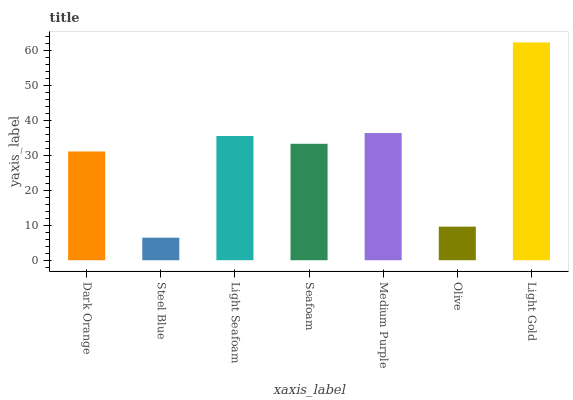Is Light Seafoam the minimum?
Answer yes or no. No. Is Light Seafoam the maximum?
Answer yes or no. No. Is Light Seafoam greater than Steel Blue?
Answer yes or no. Yes. Is Steel Blue less than Light Seafoam?
Answer yes or no. Yes. Is Steel Blue greater than Light Seafoam?
Answer yes or no. No. Is Light Seafoam less than Steel Blue?
Answer yes or no. No. Is Seafoam the high median?
Answer yes or no. Yes. Is Seafoam the low median?
Answer yes or no. Yes. Is Olive the high median?
Answer yes or no. No. Is Light Seafoam the low median?
Answer yes or no. No. 